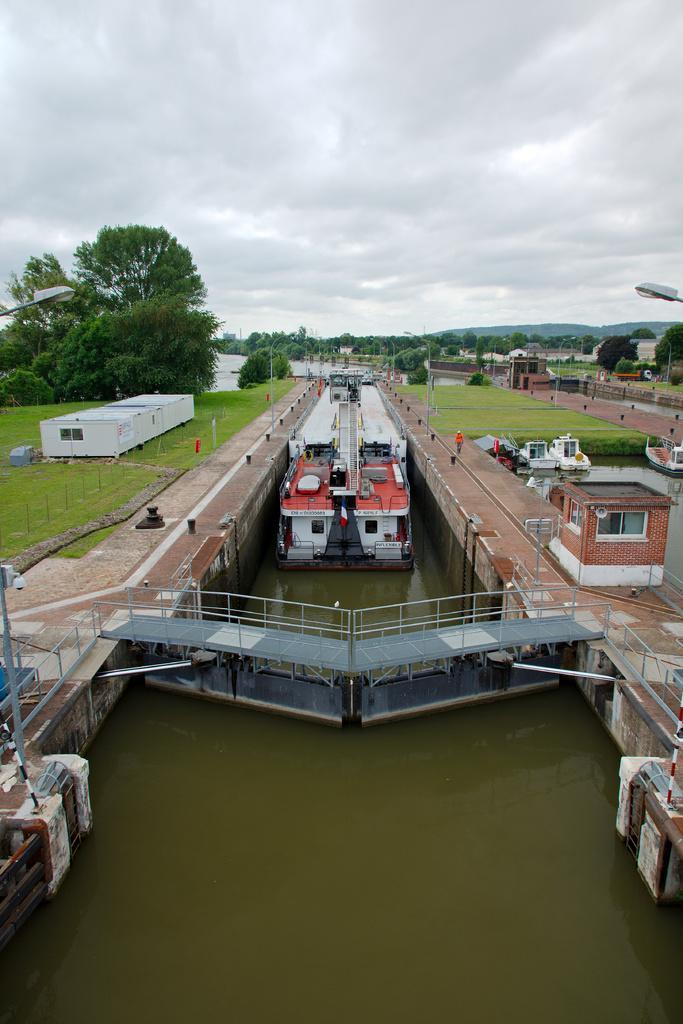Please provide a concise description of this image. In the picture we can see a water in the middle of two paths and a boat in it and on the paths we can see a grass surface with some houses, poles, trees, plants and in the background we can see trees, hills and sky with clouds. 